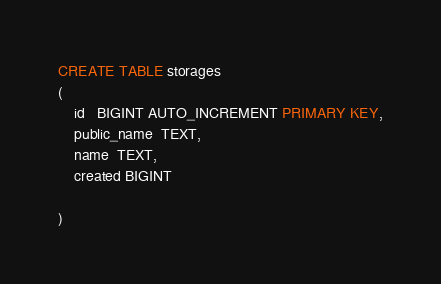Convert code to text. <code><loc_0><loc_0><loc_500><loc_500><_SQL_>CREATE TABLE storages
(
    id   BIGINT AUTO_INCREMENT PRIMARY KEY,
    public_name  TEXT,
    name  TEXT,
    created BIGINT

)</code> 